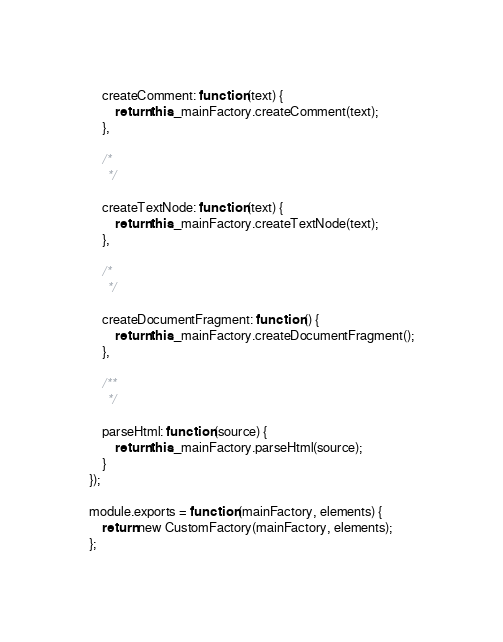<code> <loc_0><loc_0><loc_500><loc_500><_JavaScript_>	createComment: function (text) {
		return this._mainFactory.createComment(text);
	},

	/*
	 */

	createTextNode: function (text) {
		return this._mainFactory.createTextNode(text);
	},

	/*
	 */

	createDocumentFragment: function () {
		return this._mainFactory.createDocumentFragment();
	},

	/**
	 */

	parseHtml: function (source) {
		return this._mainFactory.parseHtml(source);
	}
});

module.exports = function (mainFactory, elements) {
	return new CustomFactory(mainFactory, elements);
};
</code> 